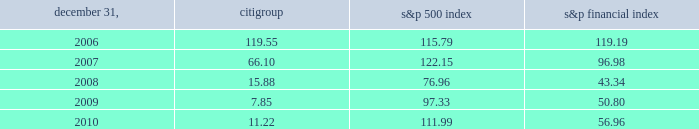Dividends for a summary of the cash dividends paid on citi 2019s outstanding common stock during 2009 and 2010 , see note 33 to the consolidated financial statements .
For so long as the u.s .
Government holds any citigroup trust preferred securities acquired pursuant to the exchange offers consummated in 2009 , citigroup has agreed not to pay a quarterly common stock dividend exceeding $ 0.01 per quarter , subject to certain customary exceptions .
Further , any dividend on citi 2019s outstanding common stock would need to be made in compliance with citi 2019s obligations to any remaining outstanding citigroup preferred stock .
Performance graph comparison of five-year cumulative total return the following graph and table compare the cumulative total return on citigroup 2019s common stock with the cumulative total return of the s&p 500 index and the s&p financial index over the five-year period extending through december 31 , 2010 .
The graph and table assume that $ 100 was invested on december 31 , 2005 in citigroup 2019s common stock , the s&p 500 index and the s&p financial index and that all dividends were reinvested .
Citigroup s&p 500 index s&p financial index comparison of five-year cumulative total return for the years ended 2006 2007 2008 2009 2010 .

What was the difference in percentage cumulative total return between cititgroup's common stock and the s&p 500 index for the five year period ending 2010? 
Computations: (((11.22 - 100) / 100) - (56.96 - 100))
Answer: 42.1522. 